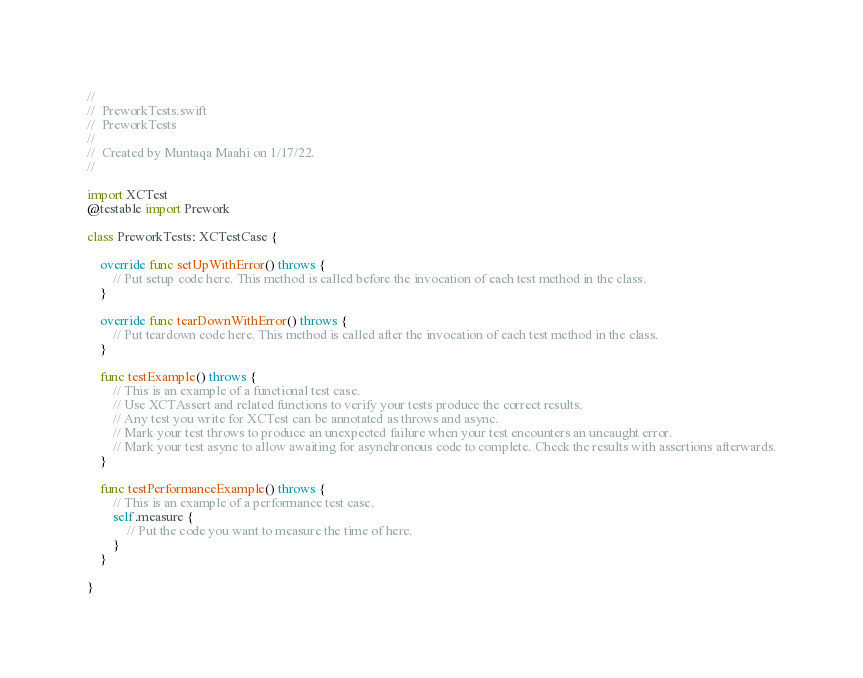<code> <loc_0><loc_0><loc_500><loc_500><_Swift_>//
//  PreworkTests.swift
//  PreworkTests
//
//  Created by Muntaqa Maahi on 1/17/22.
//

import XCTest
@testable import Prework

class PreworkTests: XCTestCase {

    override func setUpWithError() throws {
        // Put setup code here. This method is called before the invocation of each test method in the class.
    }

    override func tearDownWithError() throws {
        // Put teardown code here. This method is called after the invocation of each test method in the class.
    }

    func testExample() throws {
        // This is an example of a functional test case.
        // Use XCTAssert and related functions to verify your tests produce the correct results.
        // Any test you write for XCTest can be annotated as throws and async.
        // Mark your test throws to produce an unexpected failure when your test encounters an uncaught error.
        // Mark your test async to allow awaiting for asynchronous code to complete. Check the results with assertions afterwards.
    }

    func testPerformanceExample() throws {
        // This is an example of a performance test case.
        self.measure {
            // Put the code you want to measure the time of here.
        }
    }

}
</code> 